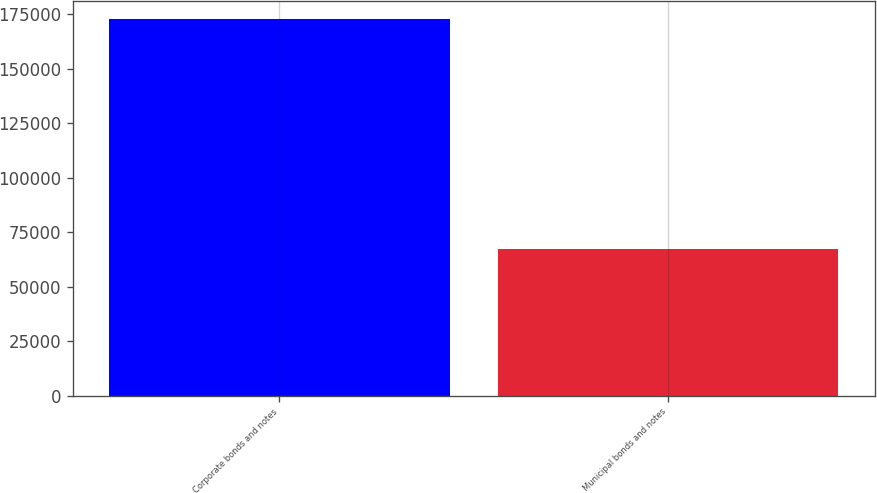<chart> <loc_0><loc_0><loc_500><loc_500><bar_chart><fcel>Corporate bonds and notes<fcel>Municipal bonds and notes<nl><fcel>172493<fcel>67409<nl></chart> 